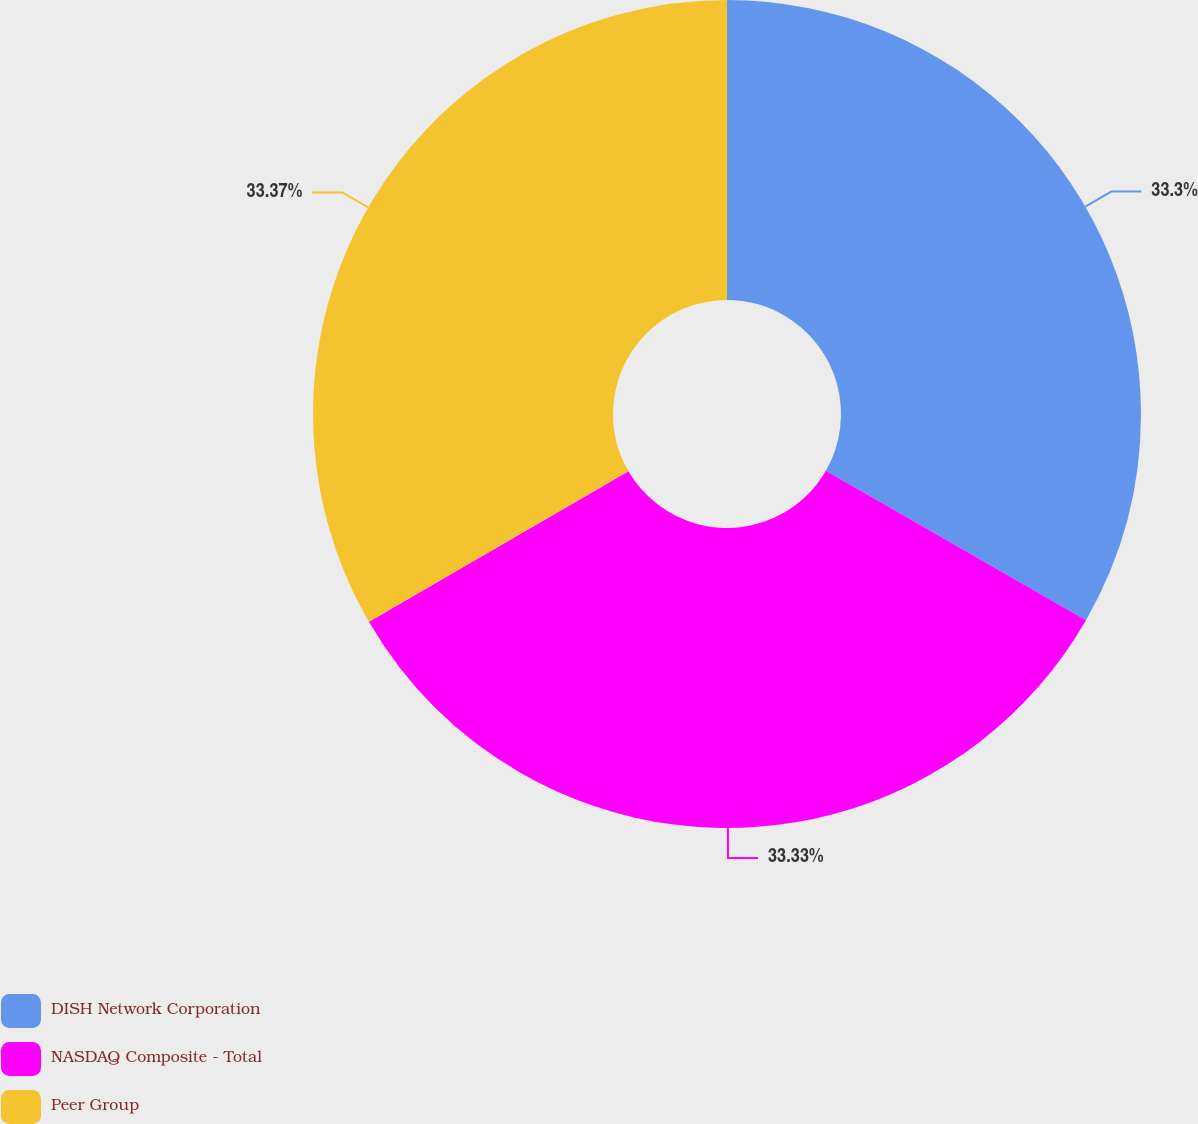Convert chart. <chart><loc_0><loc_0><loc_500><loc_500><pie_chart><fcel>DISH Network Corporation<fcel>NASDAQ Composite - Total<fcel>Peer Group<nl><fcel>33.3%<fcel>33.33%<fcel>33.37%<nl></chart> 